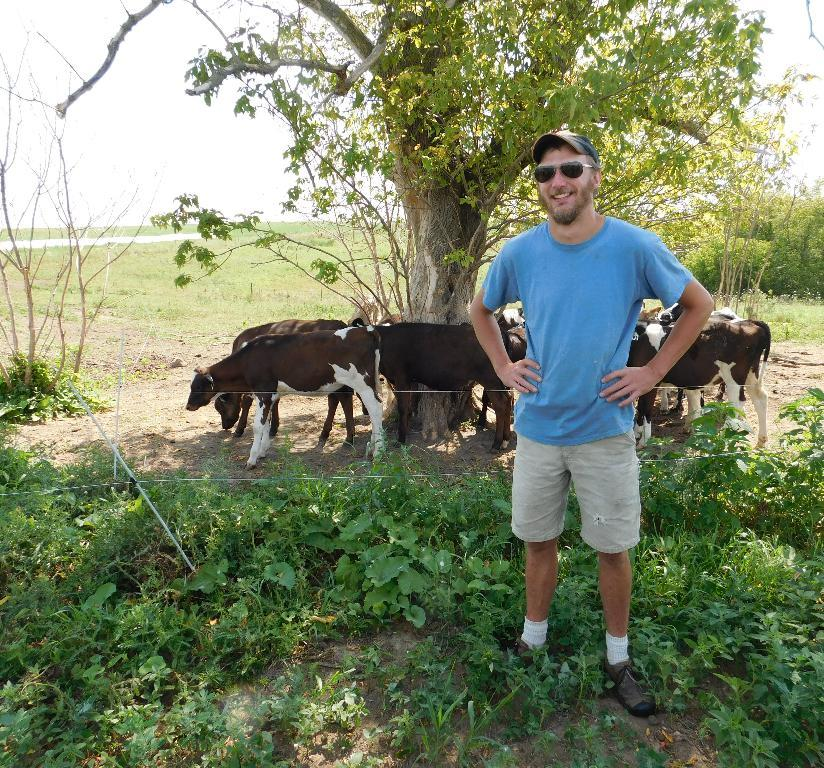What is the main subject of the image? The main subject of the image is a man. Can you describe the man's attire? The man is wearing a cap and goggles. What is the man's position in the image? The man is standing on the ground. How is the man feeling in the image? The man is smiling. What can be seen in the background of the image? In the background, there are plants, a fence, animals, grass, trees, and the sky. What type of crime is being committed in the image? There is no crime being committed in the image; it features a man standing on the ground with a smile on his face. Can you see any fairies flying around in the image? There are no fairies present in the image. 